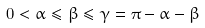Convert formula to latex. <formula><loc_0><loc_0><loc_500><loc_500>0 < \alpha \leq \beta \leq \gamma = \pi - \alpha - \beta</formula> 